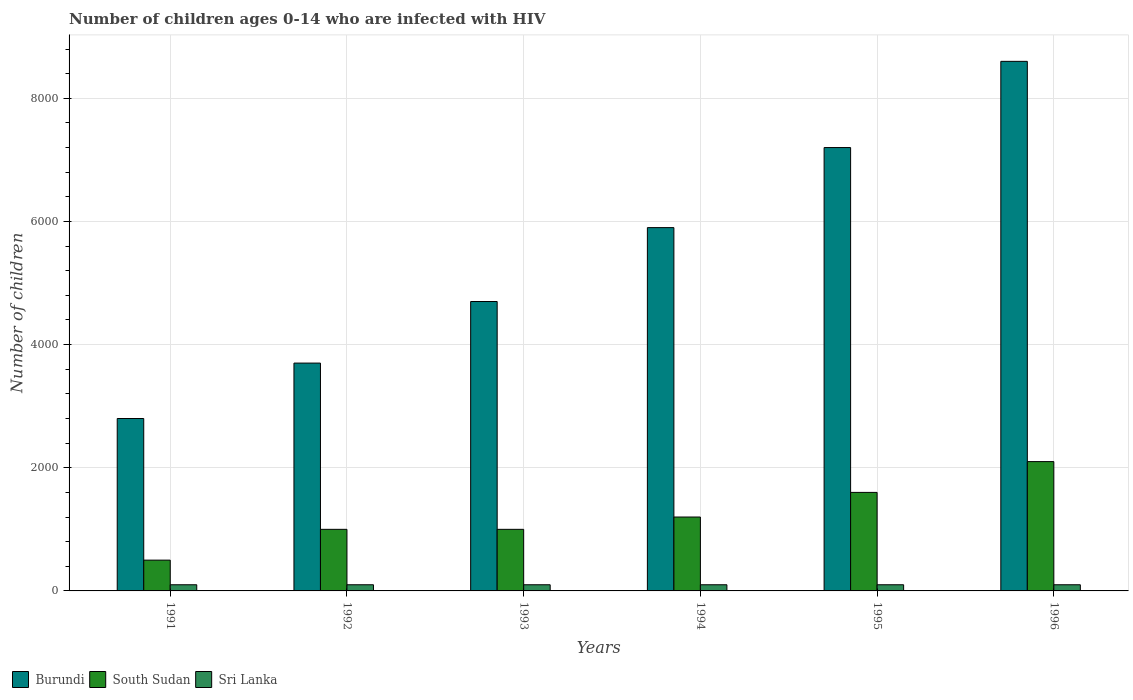How many groups of bars are there?
Give a very brief answer. 6. Are the number of bars per tick equal to the number of legend labels?
Give a very brief answer. Yes. Are the number of bars on each tick of the X-axis equal?
Make the answer very short. Yes. How many bars are there on the 2nd tick from the left?
Ensure brevity in your answer.  3. What is the number of HIV infected children in Sri Lanka in 1995?
Your answer should be compact. 100. Across all years, what is the maximum number of HIV infected children in South Sudan?
Ensure brevity in your answer.  2100. Across all years, what is the minimum number of HIV infected children in Burundi?
Ensure brevity in your answer.  2800. In which year was the number of HIV infected children in Sri Lanka minimum?
Offer a terse response. 1991. What is the total number of HIV infected children in South Sudan in the graph?
Offer a very short reply. 7400. What is the difference between the number of HIV infected children in South Sudan in 1991 and that in 1994?
Your answer should be very brief. -700. What is the difference between the number of HIV infected children in South Sudan in 1991 and the number of HIV infected children in Sri Lanka in 1994?
Offer a terse response. 400. What is the average number of HIV infected children in Sri Lanka per year?
Your answer should be very brief. 100. In the year 1994, what is the difference between the number of HIV infected children in South Sudan and number of HIV infected children in Burundi?
Offer a very short reply. -4700. In how many years, is the number of HIV infected children in Sri Lanka greater than 5200?
Your answer should be compact. 0. Is the number of HIV infected children in Sri Lanka in 1993 less than that in 1996?
Provide a short and direct response. No. Is the difference between the number of HIV infected children in South Sudan in 1994 and 1996 greater than the difference between the number of HIV infected children in Burundi in 1994 and 1996?
Give a very brief answer. Yes. What is the difference between the highest and the second highest number of HIV infected children in Burundi?
Provide a short and direct response. 1400. What is the difference between the highest and the lowest number of HIV infected children in Burundi?
Provide a succinct answer. 5800. Is the sum of the number of HIV infected children in Burundi in 1992 and 1996 greater than the maximum number of HIV infected children in Sri Lanka across all years?
Your answer should be very brief. Yes. What does the 3rd bar from the left in 1992 represents?
Your response must be concise. Sri Lanka. What does the 1st bar from the right in 1992 represents?
Give a very brief answer. Sri Lanka. Is it the case that in every year, the sum of the number of HIV infected children in Sri Lanka and number of HIV infected children in South Sudan is greater than the number of HIV infected children in Burundi?
Your answer should be compact. No. How many bars are there?
Make the answer very short. 18. Where does the legend appear in the graph?
Offer a very short reply. Bottom left. How many legend labels are there?
Make the answer very short. 3. How are the legend labels stacked?
Offer a very short reply. Horizontal. What is the title of the graph?
Provide a short and direct response. Number of children ages 0-14 who are infected with HIV. Does "Lao PDR" appear as one of the legend labels in the graph?
Your answer should be compact. No. What is the label or title of the X-axis?
Offer a very short reply. Years. What is the label or title of the Y-axis?
Provide a succinct answer. Number of children. What is the Number of children in Burundi in 1991?
Make the answer very short. 2800. What is the Number of children of Burundi in 1992?
Provide a short and direct response. 3700. What is the Number of children of Burundi in 1993?
Offer a very short reply. 4700. What is the Number of children in Sri Lanka in 1993?
Offer a terse response. 100. What is the Number of children in Burundi in 1994?
Provide a short and direct response. 5900. What is the Number of children of South Sudan in 1994?
Offer a very short reply. 1200. What is the Number of children in Burundi in 1995?
Offer a very short reply. 7200. What is the Number of children of South Sudan in 1995?
Make the answer very short. 1600. What is the Number of children in Sri Lanka in 1995?
Your answer should be compact. 100. What is the Number of children of Burundi in 1996?
Keep it short and to the point. 8600. What is the Number of children in South Sudan in 1996?
Ensure brevity in your answer.  2100. Across all years, what is the maximum Number of children of Burundi?
Your answer should be compact. 8600. Across all years, what is the maximum Number of children in South Sudan?
Make the answer very short. 2100. Across all years, what is the maximum Number of children in Sri Lanka?
Give a very brief answer. 100. Across all years, what is the minimum Number of children of Burundi?
Your answer should be very brief. 2800. Across all years, what is the minimum Number of children of South Sudan?
Your answer should be compact. 500. Across all years, what is the minimum Number of children of Sri Lanka?
Make the answer very short. 100. What is the total Number of children in Burundi in the graph?
Provide a succinct answer. 3.29e+04. What is the total Number of children of South Sudan in the graph?
Keep it short and to the point. 7400. What is the total Number of children of Sri Lanka in the graph?
Your answer should be compact. 600. What is the difference between the Number of children in Burundi in 1991 and that in 1992?
Provide a short and direct response. -900. What is the difference between the Number of children of South Sudan in 1991 and that in 1992?
Ensure brevity in your answer.  -500. What is the difference between the Number of children of Sri Lanka in 1991 and that in 1992?
Your answer should be compact. 0. What is the difference between the Number of children of Burundi in 1991 and that in 1993?
Your answer should be compact. -1900. What is the difference between the Number of children in South Sudan in 1991 and that in 1993?
Offer a terse response. -500. What is the difference between the Number of children in Sri Lanka in 1991 and that in 1993?
Your answer should be compact. 0. What is the difference between the Number of children of Burundi in 1991 and that in 1994?
Offer a terse response. -3100. What is the difference between the Number of children in South Sudan in 1991 and that in 1994?
Offer a very short reply. -700. What is the difference between the Number of children in Burundi in 1991 and that in 1995?
Keep it short and to the point. -4400. What is the difference between the Number of children in South Sudan in 1991 and that in 1995?
Make the answer very short. -1100. What is the difference between the Number of children of Sri Lanka in 1991 and that in 1995?
Make the answer very short. 0. What is the difference between the Number of children of Burundi in 1991 and that in 1996?
Make the answer very short. -5800. What is the difference between the Number of children of South Sudan in 1991 and that in 1996?
Offer a terse response. -1600. What is the difference between the Number of children in Sri Lanka in 1991 and that in 1996?
Ensure brevity in your answer.  0. What is the difference between the Number of children of Burundi in 1992 and that in 1993?
Offer a very short reply. -1000. What is the difference between the Number of children in Burundi in 1992 and that in 1994?
Your answer should be compact. -2200. What is the difference between the Number of children of South Sudan in 1992 and that in 1994?
Offer a terse response. -200. What is the difference between the Number of children in Sri Lanka in 1992 and that in 1994?
Your answer should be very brief. 0. What is the difference between the Number of children in Burundi in 1992 and that in 1995?
Keep it short and to the point. -3500. What is the difference between the Number of children in South Sudan in 1992 and that in 1995?
Provide a succinct answer. -600. What is the difference between the Number of children in Burundi in 1992 and that in 1996?
Provide a succinct answer. -4900. What is the difference between the Number of children in South Sudan in 1992 and that in 1996?
Your response must be concise. -1100. What is the difference between the Number of children in Sri Lanka in 1992 and that in 1996?
Provide a short and direct response. 0. What is the difference between the Number of children of Burundi in 1993 and that in 1994?
Give a very brief answer. -1200. What is the difference between the Number of children in South Sudan in 1993 and that in 1994?
Your response must be concise. -200. What is the difference between the Number of children in Sri Lanka in 1993 and that in 1994?
Make the answer very short. 0. What is the difference between the Number of children of Burundi in 1993 and that in 1995?
Your answer should be very brief. -2500. What is the difference between the Number of children in South Sudan in 1993 and that in 1995?
Your answer should be compact. -600. What is the difference between the Number of children of Sri Lanka in 1993 and that in 1995?
Your answer should be very brief. 0. What is the difference between the Number of children in Burundi in 1993 and that in 1996?
Your answer should be compact. -3900. What is the difference between the Number of children in South Sudan in 1993 and that in 1996?
Your response must be concise. -1100. What is the difference between the Number of children in Burundi in 1994 and that in 1995?
Provide a short and direct response. -1300. What is the difference between the Number of children of South Sudan in 1994 and that in 1995?
Provide a short and direct response. -400. What is the difference between the Number of children in Burundi in 1994 and that in 1996?
Ensure brevity in your answer.  -2700. What is the difference between the Number of children in South Sudan in 1994 and that in 1996?
Provide a short and direct response. -900. What is the difference between the Number of children in Sri Lanka in 1994 and that in 1996?
Your response must be concise. 0. What is the difference between the Number of children of Burundi in 1995 and that in 1996?
Your response must be concise. -1400. What is the difference between the Number of children in South Sudan in 1995 and that in 1996?
Provide a succinct answer. -500. What is the difference between the Number of children in Burundi in 1991 and the Number of children in South Sudan in 1992?
Give a very brief answer. 1800. What is the difference between the Number of children in Burundi in 1991 and the Number of children in Sri Lanka in 1992?
Offer a terse response. 2700. What is the difference between the Number of children of Burundi in 1991 and the Number of children of South Sudan in 1993?
Provide a succinct answer. 1800. What is the difference between the Number of children of Burundi in 1991 and the Number of children of Sri Lanka in 1993?
Provide a succinct answer. 2700. What is the difference between the Number of children of South Sudan in 1991 and the Number of children of Sri Lanka in 1993?
Give a very brief answer. 400. What is the difference between the Number of children of Burundi in 1991 and the Number of children of South Sudan in 1994?
Offer a very short reply. 1600. What is the difference between the Number of children in Burundi in 1991 and the Number of children in Sri Lanka in 1994?
Give a very brief answer. 2700. What is the difference between the Number of children in Burundi in 1991 and the Number of children in South Sudan in 1995?
Your answer should be compact. 1200. What is the difference between the Number of children of Burundi in 1991 and the Number of children of Sri Lanka in 1995?
Offer a terse response. 2700. What is the difference between the Number of children of South Sudan in 1991 and the Number of children of Sri Lanka in 1995?
Your response must be concise. 400. What is the difference between the Number of children in Burundi in 1991 and the Number of children in South Sudan in 1996?
Provide a short and direct response. 700. What is the difference between the Number of children of Burundi in 1991 and the Number of children of Sri Lanka in 1996?
Provide a succinct answer. 2700. What is the difference between the Number of children in South Sudan in 1991 and the Number of children in Sri Lanka in 1996?
Your response must be concise. 400. What is the difference between the Number of children of Burundi in 1992 and the Number of children of South Sudan in 1993?
Provide a short and direct response. 2700. What is the difference between the Number of children of Burundi in 1992 and the Number of children of Sri Lanka in 1993?
Your response must be concise. 3600. What is the difference between the Number of children of South Sudan in 1992 and the Number of children of Sri Lanka in 1993?
Make the answer very short. 900. What is the difference between the Number of children of Burundi in 1992 and the Number of children of South Sudan in 1994?
Your answer should be compact. 2500. What is the difference between the Number of children in Burundi in 1992 and the Number of children in Sri Lanka in 1994?
Make the answer very short. 3600. What is the difference between the Number of children of South Sudan in 1992 and the Number of children of Sri Lanka in 1994?
Ensure brevity in your answer.  900. What is the difference between the Number of children in Burundi in 1992 and the Number of children in South Sudan in 1995?
Keep it short and to the point. 2100. What is the difference between the Number of children of Burundi in 1992 and the Number of children of Sri Lanka in 1995?
Ensure brevity in your answer.  3600. What is the difference between the Number of children in South Sudan in 1992 and the Number of children in Sri Lanka in 1995?
Provide a short and direct response. 900. What is the difference between the Number of children in Burundi in 1992 and the Number of children in South Sudan in 1996?
Your answer should be very brief. 1600. What is the difference between the Number of children in Burundi in 1992 and the Number of children in Sri Lanka in 1996?
Provide a short and direct response. 3600. What is the difference between the Number of children in South Sudan in 1992 and the Number of children in Sri Lanka in 1996?
Offer a terse response. 900. What is the difference between the Number of children in Burundi in 1993 and the Number of children in South Sudan in 1994?
Give a very brief answer. 3500. What is the difference between the Number of children of Burundi in 1993 and the Number of children of Sri Lanka in 1994?
Provide a succinct answer. 4600. What is the difference between the Number of children of South Sudan in 1993 and the Number of children of Sri Lanka in 1994?
Your answer should be very brief. 900. What is the difference between the Number of children in Burundi in 1993 and the Number of children in South Sudan in 1995?
Ensure brevity in your answer.  3100. What is the difference between the Number of children of Burundi in 1993 and the Number of children of Sri Lanka in 1995?
Provide a succinct answer. 4600. What is the difference between the Number of children in South Sudan in 1993 and the Number of children in Sri Lanka in 1995?
Your answer should be compact. 900. What is the difference between the Number of children of Burundi in 1993 and the Number of children of South Sudan in 1996?
Your response must be concise. 2600. What is the difference between the Number of children of Burundi in 1993 and the Number of children of Sri Lanka in 1996?
Offer a terse response. 4600. What is the difference between the Number of children in South Sudan in 1993 and the Number of children in Sri Lanka in 1996?
Your answer should be very brief. 900. What is the difference between the Number of children in Burundi in 1994 and the Number of children in South Sudan in 1995?
Give a very brief answer. 4300. What is the difference between the Number of children in Burundi in 1994 and the Number of children in Sri Lanka in 1995?
Give a very brief answer. 5800. What is the difference between the Number of children of South Sudan in 1994 and the Number of children of Sri Lanka in 1995?
Keep it short and to the point. 1100. What is the difference between the Number of children of Burundi in 1994 and the Number of children of South Sudan in 1996?
Ensure brevity in your answer.  3800. What is the difference between the Number of children in Burundi in 1994 and the Number of children in Sri Lanka in 1996?
Give a very brief answer. 5800. What is the difference between the Number of children of South Sudan in 1994 and the Number of children of Sri Lanka in 1996?
Your answer should be very brief. 1100. What is the difference between the Number of children of Burundi in 1995 and the Number of children of South Sudan in 1996?
Your response must be concise. 5100. What is the difference between the Number of children in Burundi in 1995 and the Number of children in Sri Lanka in 1996?
Your answer should be compact. 7100. What is the difference between the Number of children of South Sudan in 1995 and the Number of children of Sri Lanka in 1996?
Your answer should be very brief. 1500. What is the average Number of children in Burundi per year?
Offer a very short reply. 5483.33. What is the average Number of children in South Sudan per year?
Make the answer very short. 1233.33. In the year 1991, what is the difference between the Number of children of Burundi and Number of children of South Sudan?
Your answer should be very brief. 2300. In the year 1991, what is the difference between the Number of children in Burundi and Number of children in Sri Lanka?
Your answer should be very brief. 2700. In the year 1991, what is the difference between the Number of children of South Sudan and Number of children of Sri Lanka?
Your response must be concise. 400. In the year 1992, what is the difference between the Number of children in Burundi and Number of children in South Sudan?
Your response must be concise. 2700. In the year 1992, what is the difference between the Number of children in Burundi and Number of children in Sri Lanka?
Your answer should be compact. 3600. In the year 1992, what is the difference between the Number of children of South Sudan and Number of children of Sri Lanka?
Your response must be concise. 900. In the year 1993, what is the difference between the Number of children in Burundi and Number of children in South Sudan?
Give a very brief answer. 3700. In the year 1993, what is the difference between the Number of children of Burundi and Number of children of Sri Lanka?
Provide a succinct answer. 4600. In the year 1993, what is the difference between the Number of children in South Sudan and Number of children in Sri Lanka?
Offer a very short reply. 900. In the year 1994, what is the difference between the Number of children in Burundi and Number of children in South Sudan?
Your response must be concise. 4700. In the year 1994, what is the difference between the Number of children of Burundi and Number of children of Sri Lanka?
Ensure brevity in your answer.  5800. In the year 1994, what is the difference between the Number of children in South Sudan and Number of children in Sri Lanka?
Your answer should be very brief. 1100. In the year 1995, what is the difference between the Number of children of Burundi and Number of children of South Sudan?
Give a very brief answer. 5600. In the year 1995, what is the difference between the Number of children of Burundi and Number of children of Sri Lanka?
Provide a succinct answer. 7100. In the year 1995, what is the difference between the Number of children of South Sudan and Number of children of Sri Lanka?
Provide a succinct answer. 1500. In the year 1996, what is the difference between the Number of children in Burundi and Number of children in South Sudan?
Provide a succinct answer. 6500. In the year 1996, what is the difference between the Number of children of Burundi and Number of children of Sri Lanka?
Your answer should be very brief. 8500. What is the ratio of the Number of children in Burundi in 1991 to that in 1992?
Provide a short and direct response. 0.76. What is the ratio of the Number of children in Sri Lanka in 1991 to that in 1992?
Make the answer very short. 1. What is the ratio of the Number of children in Burundi in 1991 to that in 1993?
Give a very brief answer. 0.6. What is the ratio of the Number of children in South Sudan in 1991 to that in 1993?
Provide a succinct answer. 0.5. What is the ratio of the Number of children of Sri Lanka in 1991 to that in 1993?
Give a very brief answer. 1. What is the ratio of the Number of children of Burundi in 1991 to that in 1994?
Your answer should be compact. 0.47. What is the ratio of the Number of children of South Sudan in 1991 to that in 1994?
Offer a very short reply. 0.42. What is the ratio of the Number of children in Burundi in 1991 to that in 1995?
Provide a short and direct response. 0.39. What is the ratio of the Number of children in South Sudan in 1991 to that in 1995?
Your response must be concise. 0.31. What is the ratio of the Number of children of Sri Lanka in 1991 to that in 1995?
Offer a terse response. 1. What is the ratio of the Number of children of Burundi in 1991 to that in 1996?
Make the answer very short. 0.33. What is the ratio of the Number of children of South Sudan in 1991 to that in 1996?
Ensure brevity in your answer.  0.24. What is the ratio of the Number of children in Sri Lanka in 1991 to that in 1996?
Ensure brevity in your answer.  1. What is the ratio of the Number of children in Burundi in 1992 to that in 1993?
Provide a short and direct response. 0.79. What is the ratio of the Number of children in Burundi in 1992 to that in 1994?
Give a very brief answer. 0.63. What is the ratio of the Number of children of South Sudan in 1992 to that in 1994?
Give a very brief answer. 0.83. What is the ratio of the Number of children of Burundi in 1992 to that in 1995?
Provide a short and direct response. 0.51. What is the ratio of the Number of children of Burundi in 1992 to that in 1996?
Your response must be concise. 0.43. What is the ratio of the Number of children of South Sudan in 1992 to that in 1996?
Offer a terse response. 0.48. What is the ratio of the Number of children in Sri Lanka in 1992 to that in 1996?
Offer a very short reply. 1. What is the ratio of the Number of children in Burundi in 1993 to that in 1994?
Give a very brief answer. 0.8. What is the ratio of the Number of children in South Sudan in 1993 to that in 1994?
Provide a short and direct response. 0.83. What is the ratio of the Number of children in Sri Lanka in 1993 to that in 1994?
Ensure brevity in your answer.  1. What is the ratio of the Number of children of Burundi in 1993 to that in 1995?
Your answer should be compact. 0.65. What is the ratio of the Number of children of Sri Lanka in 1993 to that in 1995?
Keep it short and to the point. 1. What is the ratio of the Number of children of Burundi in 1993 to that in 1996?
Your response must be concise. 0.55. What is the ratio of the Number of children in South Sudan in 1993 to that in 1996?
Provide a succinct answer. 0.48. What is the ratio of the Number of children of Sri Lanka in 1993 to that in 1996?
Offer a very short reply. 1. What is the ratio of the Number of children of Burundi in 1994 to that in 1995?
Provide a short and direct response. 0.82. What is the ratio of the Number of children of Burundi in 1994 to that in 1996?
Keep it short and to the point. 0.69. What is the ratio of the Number of children of South Sudan in 1994 to that in 1996?
Provide a succinct answer. 0.57. What is the ratio of the Number of children in Burundi in 1995 to that in 1996?
Give a very brief answer. 0.84. What is the ratio of the Number of children of South Sudan in 1995 to that in 1996?
Your answer should be compact. 0.76. What is the ratio of the Number of children of Sri Lanka in 1995 to that in 1996?
Your answer should be very brief. 1. What is the difference between the highest and the second highest Number of children of Burundi?
Make the answer very short. 1400. What is the difference between the highest and the second highest Number of children of South Sudan?
Your answer should be compact. 500. What is the difference between the highest and the lowest Number of children in Burundi?
Your response must be concise. 5800. What is the difference between the highest and the lowest Number of children of South Sudan?
Your answer should be compact. 1600. 